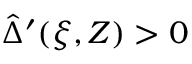<formula> <loc_0><loc_0><loc_500><loc_500>\hat { \Delta } ^ { \prime } ( \xi , Z ) > 0</formula> 